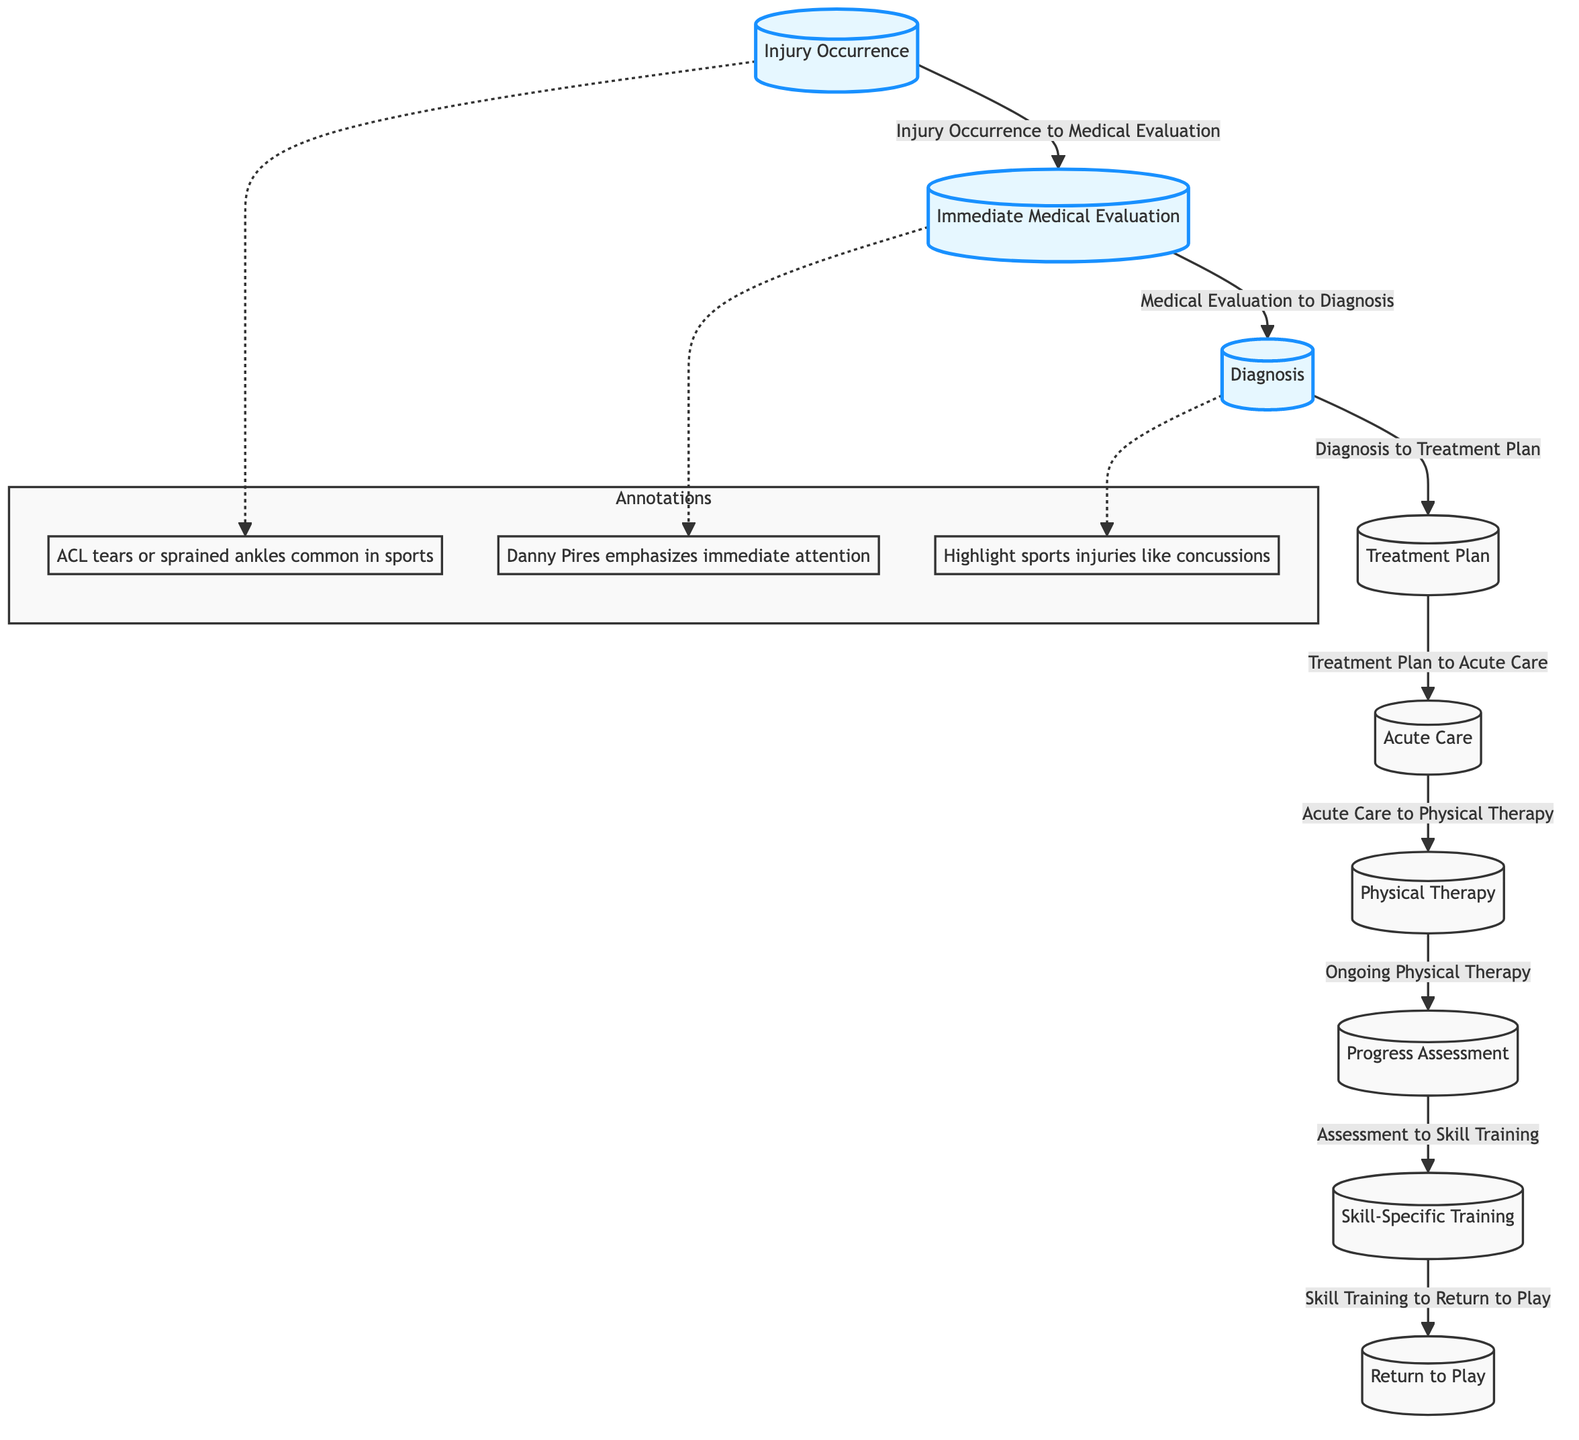What is the first step in the rehabilitation process? The first step in the rehabilitation process is "Injury Occurrence," which is the starting point of the flowchart.
Answer: Injury Occurrence How many nodes are present in the diagram? By counting each step in the flowchart from "Injury Occurrence" to "Return to Play," there are a total of 9 nodes.
Answer: 9 What follows "Physical Therapy"? After "Physical Therapy," the next step indicated in the flowchart is "Progress Assessment."
Answer: Progress Assessment Identify one common type of injury mentioned in the annotations. The flowchart's annotations mention "ACL tears" and "sprained ankles" as common sports injuries.
Answer: ACL tears What is highlighted in the diagram? The nodes "Injury Occurrence," "Immediate Medical Evaluation," and "Diagnosis" are specifically highlighted to emphasize their importance in the recovery process.
Answer: Injury Occurrence, Immediate Medical Evaluation, Diagnosis What is the last step of the rehabilitation process? The last step in the rehabilitation process is "Return to Play," which signifies the athlete's readiness to resume activities.
Answer: Return to Play What relationship does "Diagnosis" have with "Treatment Plan"? The relationship is that after "Diagnosis," the next step is to create a "Treatment Plan," indicating a sequential flow from one to the other.
Answer: Diagnosis to Treatment Plan What does Danny Pires emphasize in the flowchart? Danny Pires emphasizes the need for "immediate attention" following an injury, noted in the annotations of the diagram.
Answer: Immediate attention 